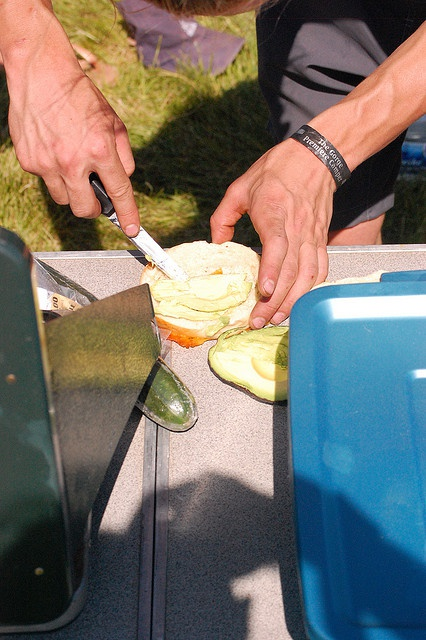Describe the objects in this image and their specific colors. I can see people in salmon, black, and gray tones, sandwich in salmon, beige, khaki, and orange tones, and knife in salmon, white, black, and gray tones in this image. 